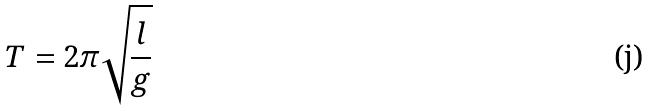<formula> <loc_0><loc_0><loc_500><loc_500>T = 2 \pi \sqrt { \frac { l } { g } }</formula> 